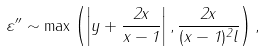Convert formula to latex. <formula><loc_0><loc_0><loc_500><loc_500>\varepsilon ^ { \prime \prime } \sim \max \left ( \left | y + \frac { 2 x } { x - 1 } \right | , \frac { 2 x } { ( x - 1 ) ^ { 2 } l } \right ) ,</formula> 